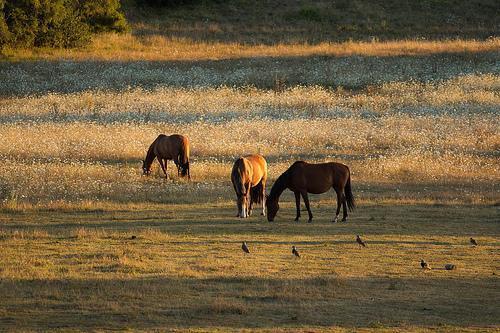How many horses?
Give a very brief answer. 3. 